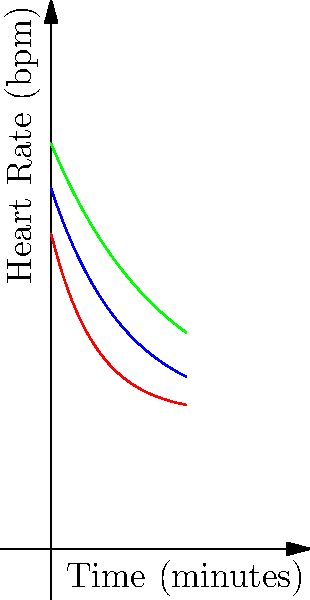The graph shows heart rate recovery curves for three different exercise intensities. Which intensity level shows the slowest rate of heart rate recovery, and what does this imply for senior fitness programs? To determine which intensity level shows the slowest rate of heart rate recovery, we need to analyze the curves:

1. The red curve represents low intensity exercise.
2. The blue curve represents moderate intensity exercise.
3. The green curve represents high intensity exercise.

We can observe that:

1. The green curve (high intensity) starts at the highest point and decreases the slowest.
2. The blue curve (moderate intensity) starts lower than the green and decreases faster.
3. The red curve (low intensity) starts the lowest and decreases the fastest.

The slowest rate of recovery is indicated by the curve that takes the longest time to return to the resting heart rate (around 60 bpm). In this case, it's the green curve representing high intensity exercise.

This implies that for senior fitness programs:

1. High intensity exercises result in a more prolonged elevated heart rate, which may not be suitable for all seniors.
2. Moderate and low intensity exercises allow for quicker heart rate recovery, which may be safer and more comfortable for many seniors.
3. The fitness program should be tailored to individual capabilities, starting with lower intensities and gradually increasing as appropriate.
4. Monitoring heart rate recovery can be a useful tool for assessing fitness levels and progress in senior exercise programs.
Answer: High intensity; suggests need for caution and individualized programming in senior fitness. 